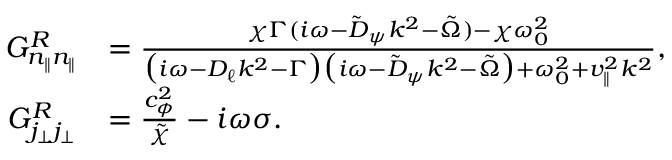Convert formula to latex. <formula><loc_0><loc_0><loc_500><loc_500>\begin{array} { r l } { G _ { n _ { \| } n _ { \| } } ^ { R } } & { = \frac { \chi \Gamma ( i \omega - \tilde { D } _ { \psi } k ^ { 2 } - \tilde { \Omega } ) - \chi \omega _ { 0 } ^ { 2 } } { \left ( i \omega - D _ { \ell } k ^ { 2 } - \Gamma \right ) \left ( i \omega - \tilde { D } _ { \psi } k ^ { 2 } - \tilde { \Omega } \right ) + \omega _ { 0 } ^ { 2 } + v _ { \| } ^ { 2 } k ^ { 2 } } , } \\ { G _ { j _ { \perp } j _ { \perp } } ^ { R } } & { = \frac { c _ { \phi } ^ { 2 } } { \tilde { \chi } } - i \omega \sigma . } \end{array}</formula> 